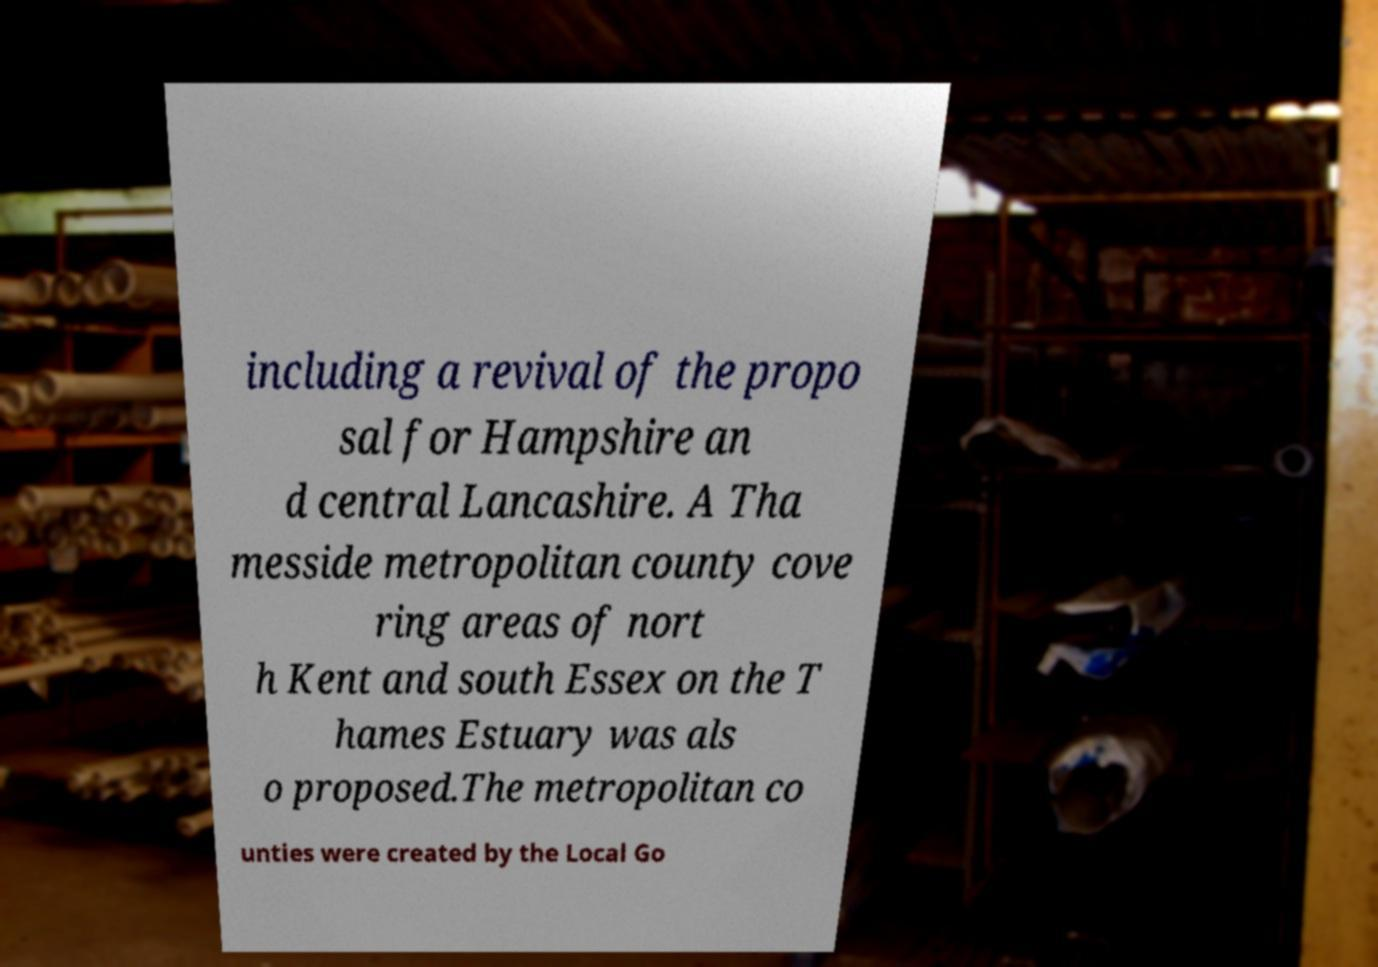Can you accurately transcribe the text from the provided image for me? including a revival of the propo sal for Hampshire an d central Lancashire. A Tha messide metropolitan county cove ring areas of nort h Kent and south Essex on the T hames Estuary was als o proposed.The metropolitan co unties were created by the Local Go 